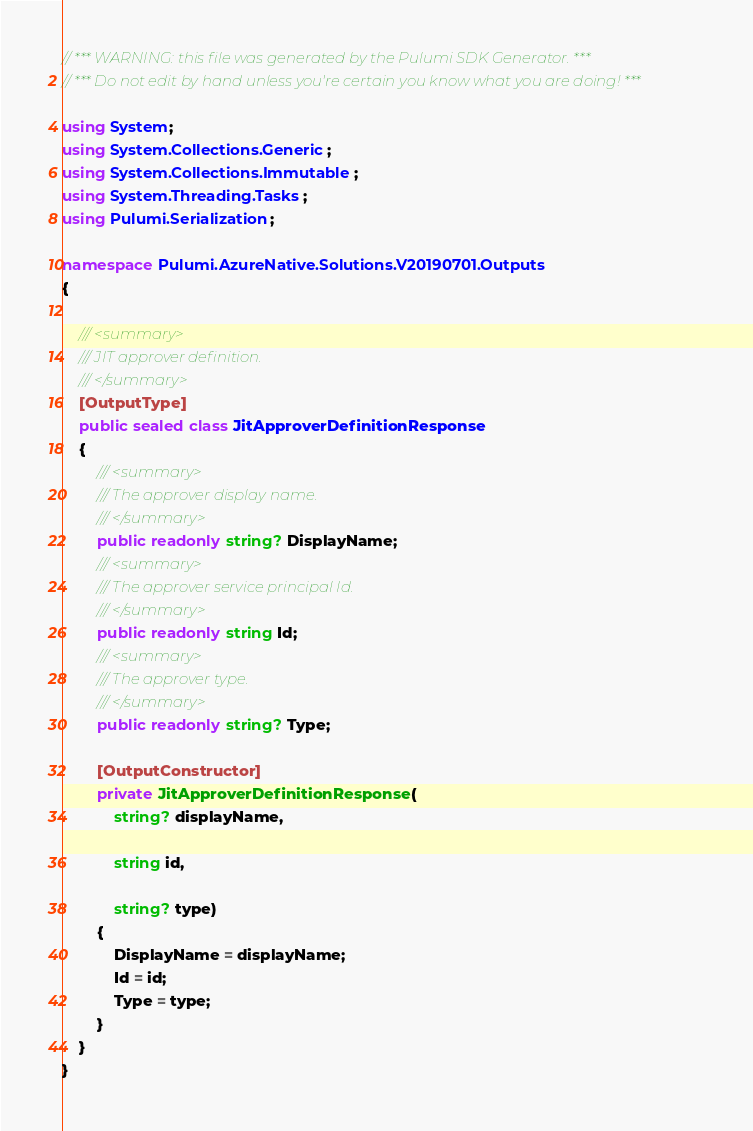<code> <loc_0><loc_0><loc_500><loc_500><_C#_>// *** WARNING: this file was generated by the Pulumi SDK Generator. ***
// *** Do not edit by hand unless you're certain you know what you are doing! ***

using System;
using System.Collections.Generic;
using System.Collections.Immutable;
using System.Threading.Tasks;
using Pulumi.Serialization;

namespace Pulumi.AzureNative.Solutions.V20190701.Outputs
{

    /// <summary>
    /// JIT approver definition.
    /// </summary>
    [OutputType]
    public sealed class JitApproverDefinitionResponse
    {
        /// <summary>
        /// The approver display name.
        /// </summary>
        public readonly string? DisplayName;
        /// <summary>
        /// The approver service principal Id.
        /// </summary>
        public readonly string Id;
        /// <summary>
        /// The approver type.
        /// </summary>
        public readonly string? Type;

        [OutputConstructor]
        private JitApproverDefinitionResponse(
            string? displayName,

            string id,

            string? type)
        {
            DisplayName = displayName;
            Id = id;
            Type = type;
        }
    }
}
</code> 